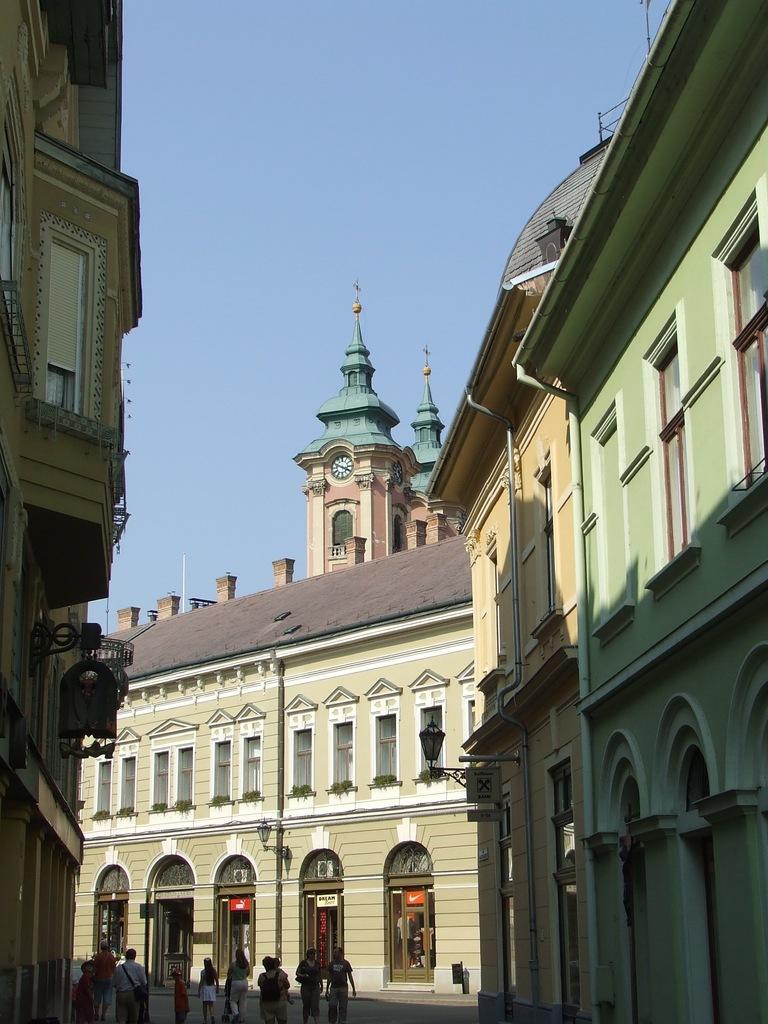In one or two sentences, can you explain what this image depicts? This is the picture of a building. In this image there are buildings and there is a clock on the tower and there are pipes on the wall. There are street lights on the footpath. At the top there is sky. At the bottom there are group of people walking on the road. 